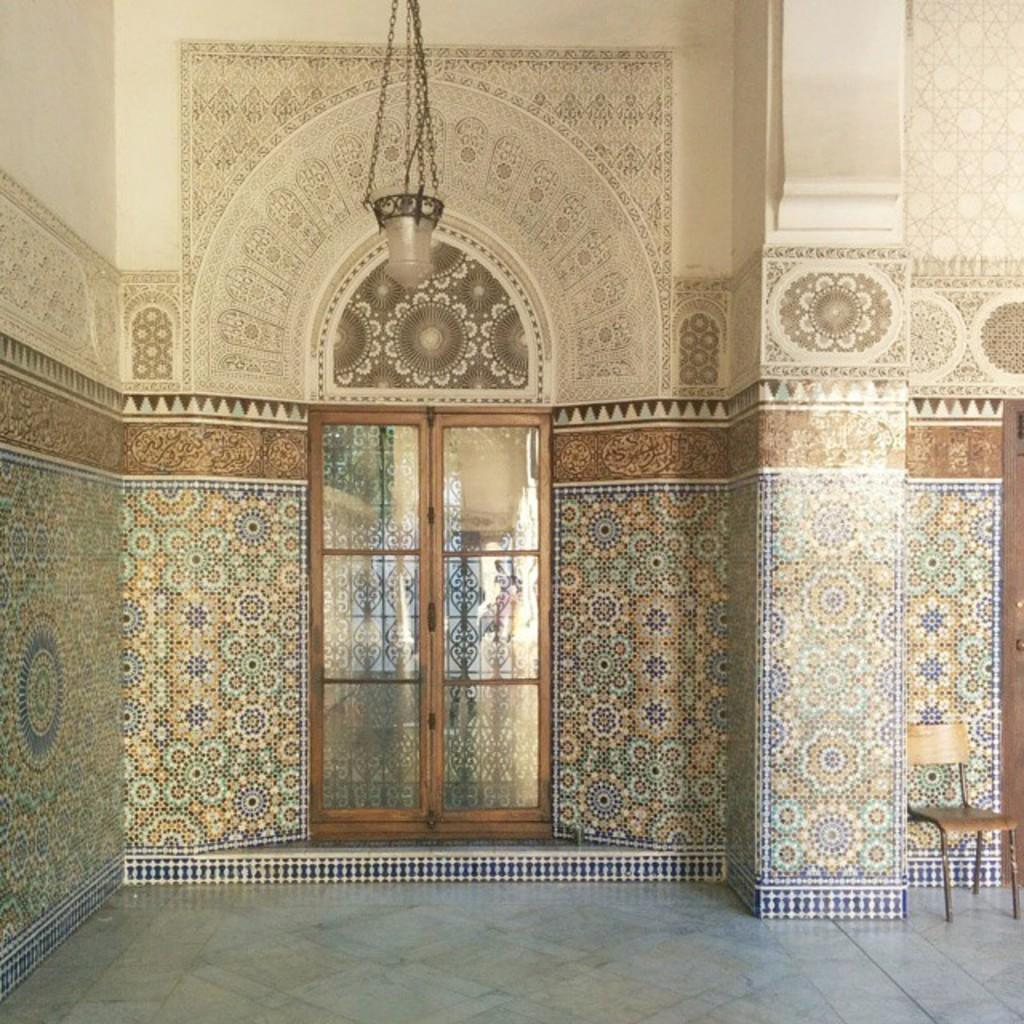Where is the setting of the image? The image appears to be inside a building. What type of furniture is present in the image? There is a chair on the floor in the image. Can you describe any lighting fixtures in the image? There is a light on the wall in the image. What type of river can be seen flowing through the shop in the image? There is no river or shop present in the image; it is inside a building with a chair and a light on the wall. 